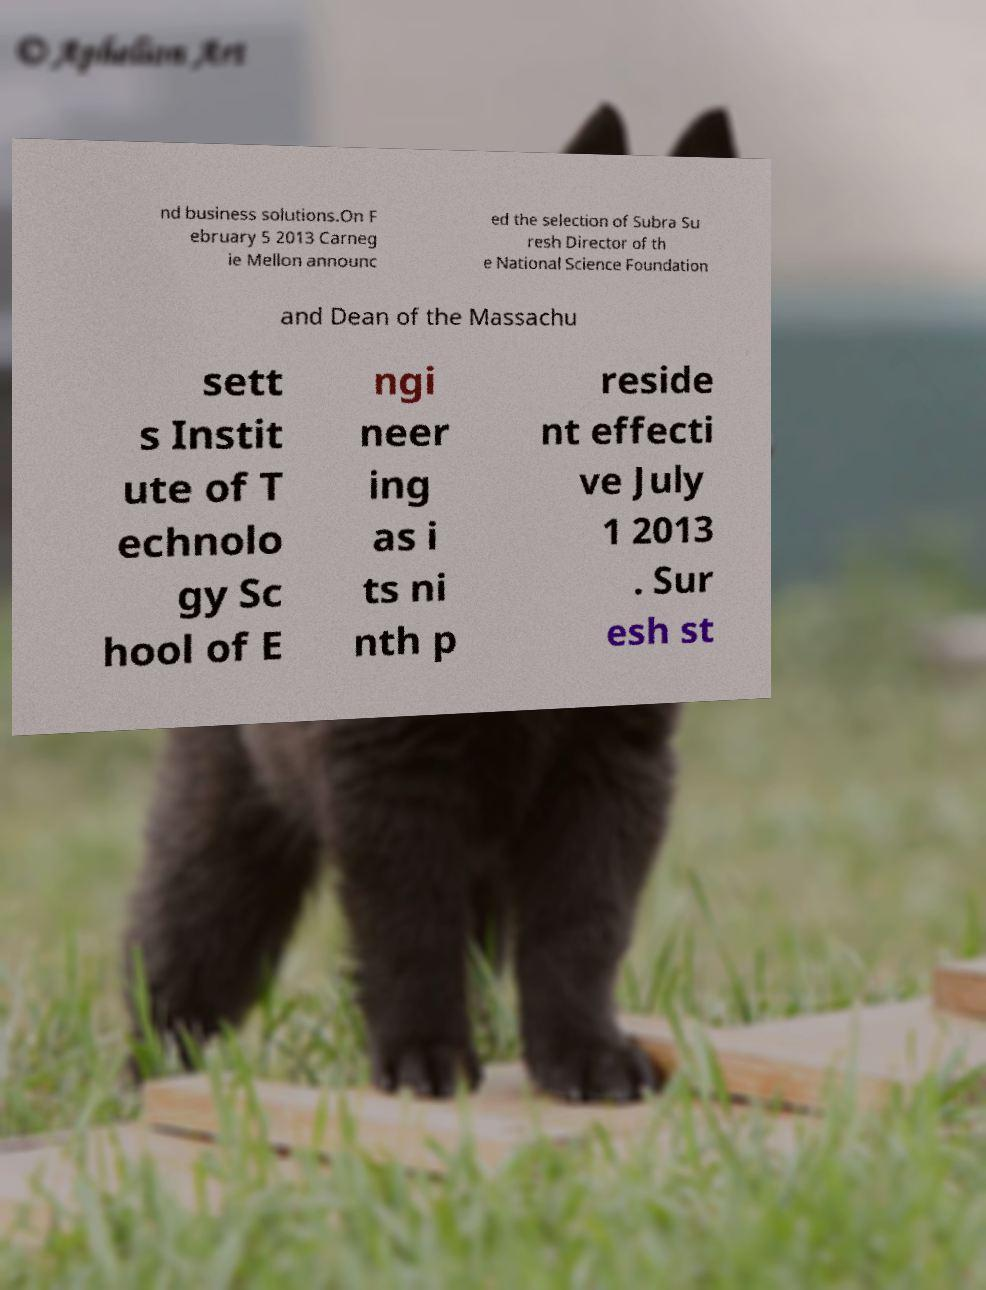Could you extract and type out the text from this image? nd business solutions.On F ebruary 5 2013 Carneg ie Mellon announc ed the selection of Subra Su resh Director of th e National Science Foundation and Dean of the Massachu sett s Instit ute of T echnolo gy Sc hool of E ngi neer ing as i ts ni nth p reside nt effecti ve July 1 2013 . Sur esh st 